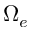<formula> <loc_0><loc_0><loc_500><loc_500>\Omega _ { e }</formula> 